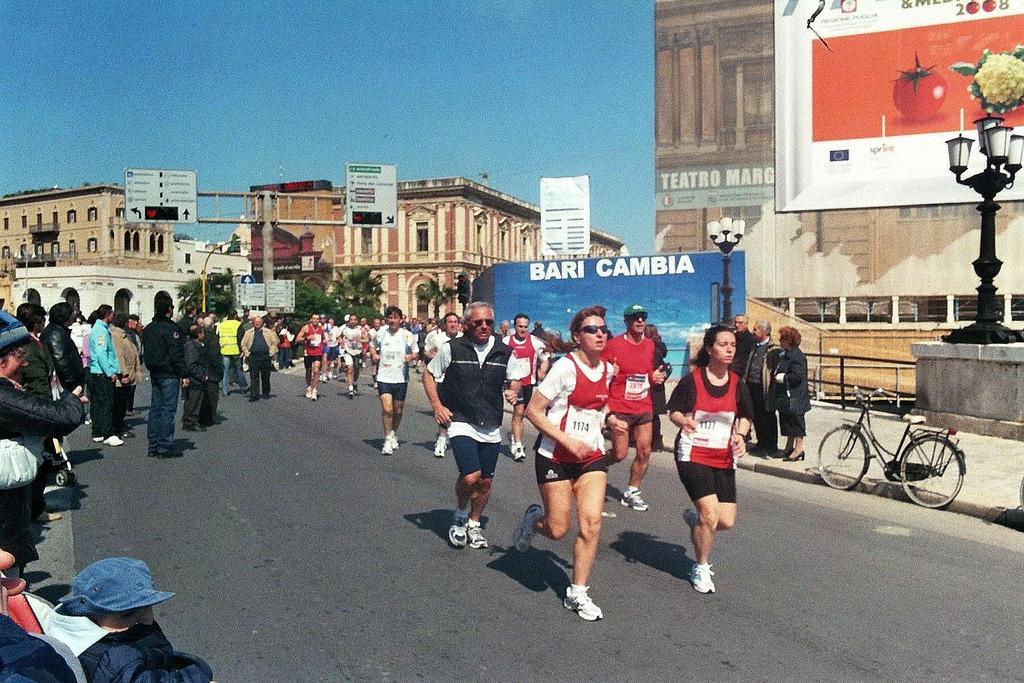Describe this image in one or two sentences. In this image I can see a road in the centre and on it I can see number of people are running. I can also see few more people are standing on the both sides of the road. In the background I can see number of buildings, poles, lights, trees, boards, the sky and on these boards I can see something is written. I can also see a bicycle on the right side of the image. 